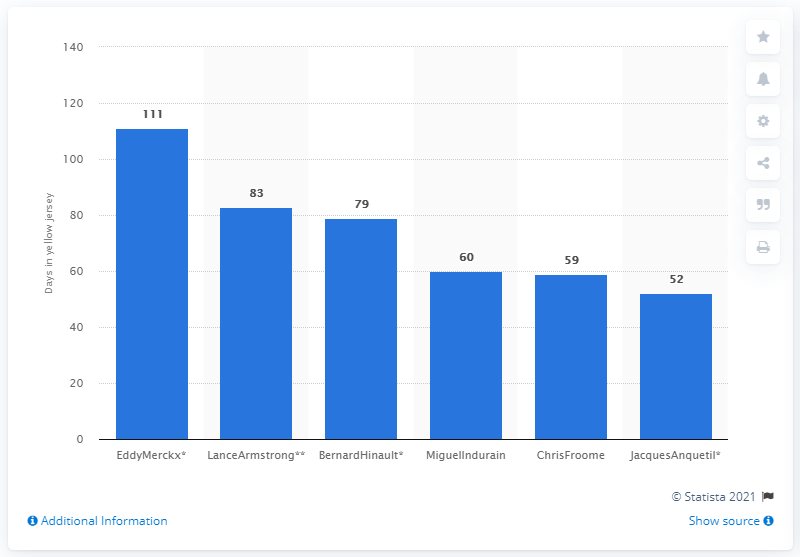Outline some significant characteristics in this image. Miguel Indurain wore the yellow jersey for a total of 60 days during his career. 